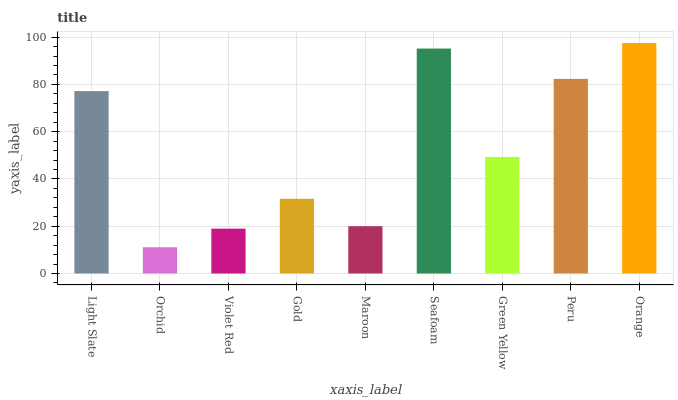Is Orchid the minimum?
Answer yes or no. Yes. Is Orange the maximum?
Answer yes or no. Yes. Is Violet Red the minimum?
Answer yes or no. No. Is Violet Red the maximum?
Answer yes or no. No. Is Violet Red greater than Orchid?
Answer yes or no. Yes. Is Orchid less than Violet Red?
Answer yes or no. Yes. Is Orchid greater than Violet Red?
Answer yes or no. No. Is Violet Red less than Orchid?
Answer yes or no. No. Is Green Yellow the high median?
Answer yes or no. Yes. Is Green Yellow the low median?
Answer yes or no. Yes. Is Light Slate the high median?
Answer yes or no. No. Is Maroon the low median?
Answer yes or no. No. 